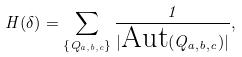<formula> <loc_0><loc_0><loc_500><loc_500>H ( \delta ) = \sum _ { \{ Q _ { a , b , c } \} } \frac { 1 } { | \text {Aut} ( Q _ { a , b , c } ) | } ,</formula> 